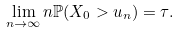Convert formula to latex. <formula><loc_0><loc_0><loc_500><loc_500>\lim _ { n \to \infty } n \mathbb { P } ( X _ { 0 } > u _ { n } ) = \tau .</formula> 